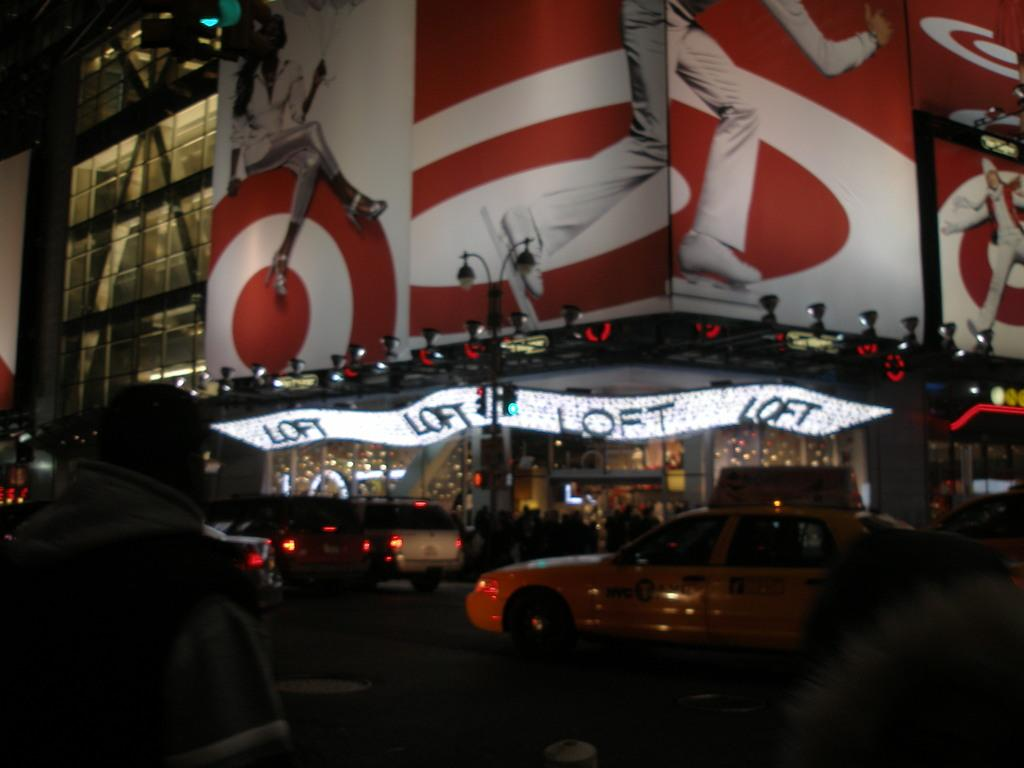Provide a one-sentence caption for the provided image. a scoreboard with the name loft on it. 